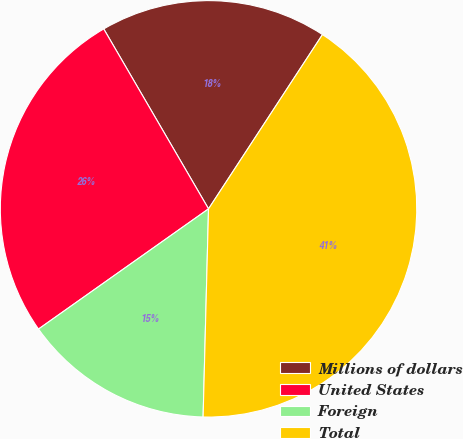Convert chart to OTSL. <chart><loc_0><loc_0><loc_500><loc_500><pie_chart><fcel>Millions of dollars<fcel>United States<fcel>Foreign<fcel>Total<nl><fcel>17.61%<fcel>26.4%<fcel>14.79%<fcel>41.2%<nl></chart> 